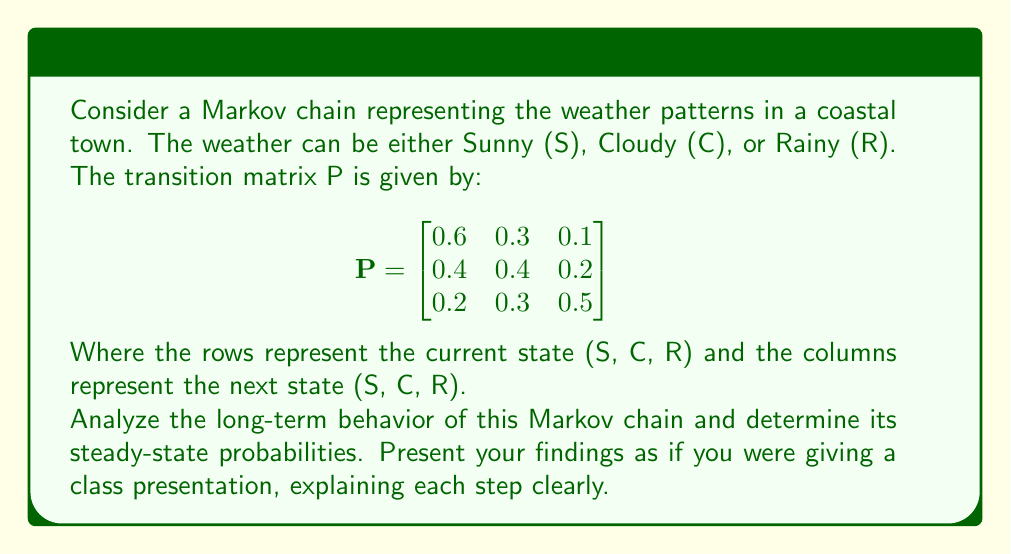Help me with this question. To analyze the long-term behavior and find the steady-state probabilities of this Markov chain, we'll follow these steps:

1) First, we need to check if the Markov chain is irreducible and aperiodic:
   - Irreducible: We can see that it's possible to go from any state to any other state in a finite number of steps.
   - Aperiodic: Each state has a self-transition probability > 0, so the chain is aperiodic.

2) Since the chain is irreducible and aperiodic, we know it has a unique steady-state distribution.

3) Let $\pi = [\pi_S, \pi_C, \pi_R]$ be the steady-state distribution. We need to solve the equation:

   $$\pi P = \pi$$

4) This gives us the system of equations:
   
   $$\begin{align}
   0.6\pi_S + 0.4\pi_C + 0.2\pi_R &= \pi_S \\
   0.3\pi_S + 0.4\pi_C + 0.3\pi_R &= \pi_C \\
   0.1\pi_S + 0.2\pi_C + 0.5\pi_R &= \pi_R
   \end{align}$$

5) We also know that $\pi_S + \pi_C + \pi_R = 1$

6) Simplifying the equations:
   
   $$\begin{align}
   0.4\pi_S - 0.4\pi_C - 0.2\pi_R &= 0 \\
   0.3\pi_S - 0.6\pi_C + 0.3\pi_R &= 0 \\
   \pi_S + \pi_C + \pi_R &= 1
   \end{align}$$

7) Solving this system of equations (using substitution or matrix methods), we get:

   $$\pi_S = \frac{10}{23} \approx 0.4348$$
   $$\pi_C = \frac{8}{23} \approx 0.3478$$
   $$\pi_R = \frac{5}{23} \approx 0.2174$$

8) These probabilities represent the long-term proportion of time the system spends in each state.

9) We can verify our solution by checking $\pi P = \pi$:

   $$[\frac{10}{23}, \frac{8}{23}, \frac{5}{23}] \begin{bmatrix}
   0.6 & 0.3 & 0.1 \\
   0.4 & 0.4 & 0.2 \\
   0.2 & 0.3 & 0.5
   \end{bmatrix} = [\frac{10}{23}, \frac{8}{23}, \frac{5}{23}]$$

This confirms our solution is correct.
Answer: The steady-state probabilities are $\pi_S = \frac{10}{23}$, $\pi_C = \frac{8}{23}$, and $\pi_R = \frac{5}{23}$. 